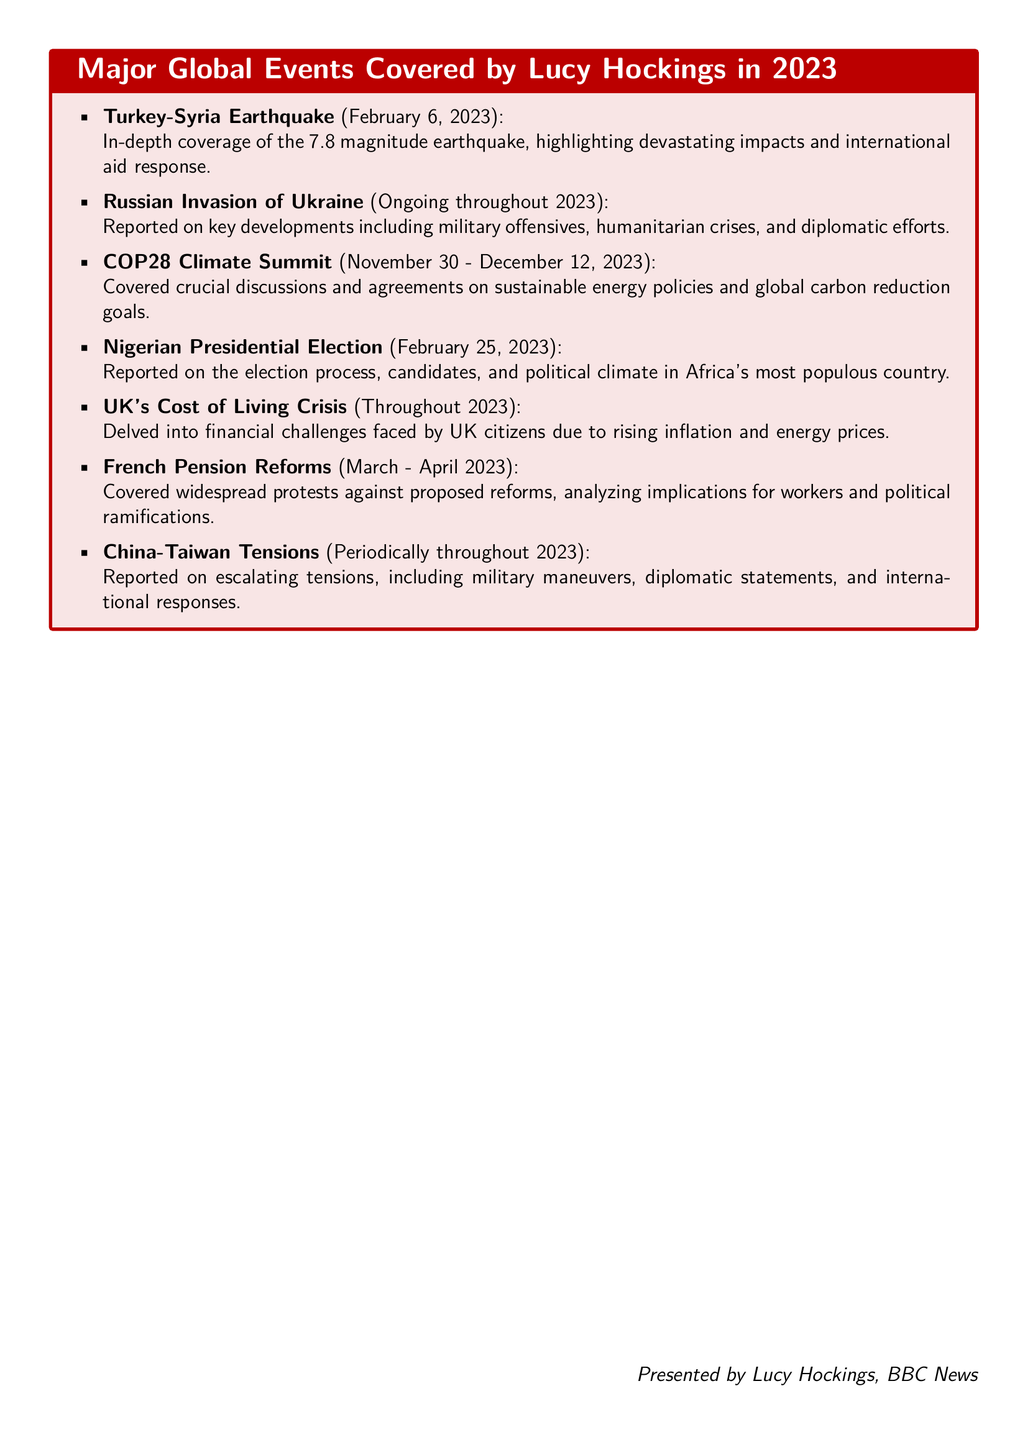What was the date of the Turkey-Syria earthquake? The document specifies that the Turkey-Syria earthquake occurred on February 6, 2023.
Answer: February 6, 2023 Which event is reported as ongoing throughout 2023? The document notes that the Russian invasion of Ukraine is ongoing throughout 2023.
Answer: Russian Invasion of Ukraine What significant summit is covered from November 30 to December 12, 2023? The document mentions the COP28 Climate Summit taking place during that period.
Answer: COP28 Climate Summit What was a major issue faced by UK citizens throughout 2023? The document highlights the cost of living crisis as a major issue faced by UK citizens throughout 2023.
Answer: Cost of Living Crisis During which months did protests related to French pension reforms take place? The document states that the protests occurred from March to April 2023.
Answer: March - April 2023 Which country had a presidential election on February 25, 2023? According to the document, Nigeria had a presidential election on that date.
Answer: Nigeria What are two major international relationships reported on periodically throughout 2023? The document discusses tensions between China and Taiwan as one of the major international relationships.
Answer: China-Taiwan Tensions Which event's reporting includes military offensives and humanitarian crises? The document outlines that the reporting on the Russian invasion of Ukraine includes military offensives and humanitarian crises.
Answer: Russian Invasion of Ukraine 